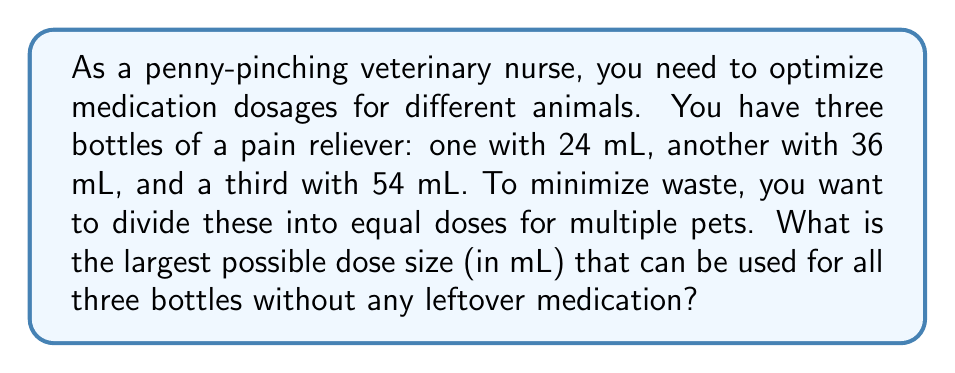Show me your answer to this math problem. To find the largest possible dose size that can be used for all three bottles without any leftover medication, we need to calculate the greatest common divisor (GCD) of 24, 36, and 54.

Let's use the Euclidean algorithm to find the GCD:

1) First, find the GCD of 24 and 36:
   $36 = 1 \times 24 + 12$
   $24 = 2 \times 12 + 0$
   So, $GCD(24, 36) = 12$

2) Now, find the GCD of 12 and 54:
   $54 = 4 \times 12 + 6$
   $12 = 2 \times 6 + 0$
   So, $GCD(12, 54) = 6$

3) Therefore, the GCD of 24, 36, and 54 is 6.

This means that 6 mL is the largest dose size that can be used for all three bottles without any leftover medication:
- The 24 mL bottle can be divided into 4 doses of 6 mL each
- The 36 mL bottle can be divided into 6 doses of 6 mL each
- The 54 mL bottle can be divided into 9 doses of 6 mL each

Using this dose size ensures no medication is wasted, which aligns with the penny-pinching nature of the veterinary nurse.
Answer: 6 mL 